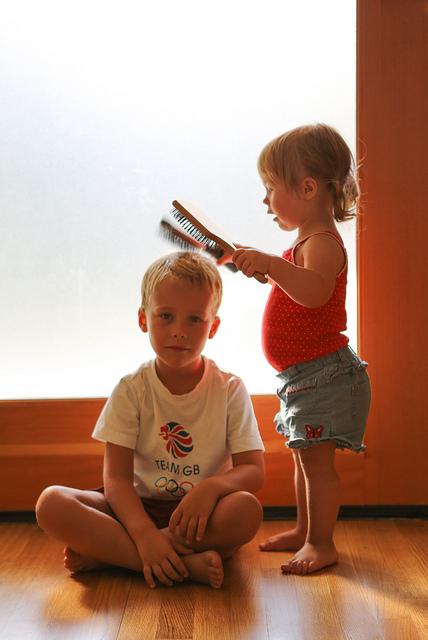Which of the boy's ear is closer to the girls stomach?
Be succinct. Left. Are there a lot of children in this photo?
Give a very brief answer. No. Is the child holding two brushes?
Concise answer only. Yes. Is the boy happy?
Write a very short answer. No. 